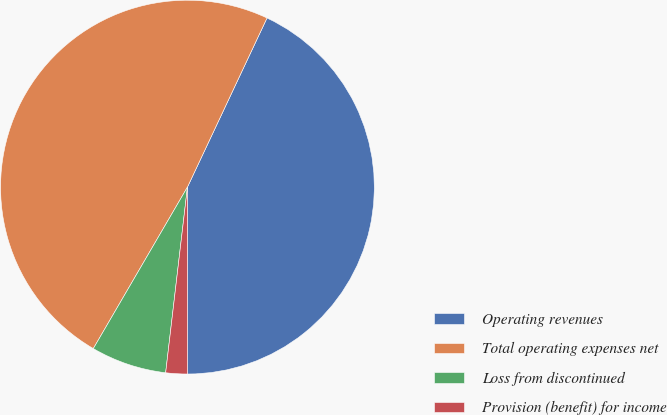Convert chart to OTSL. <chart><loc_0><loc_0><loc_500><loc_500><pie_chart><fcel>Operating revenues<fcel>Total operating expenses net<fcel>Loss from discontinued<fcel>Provision (benefit) for income<nl><fcel>42.99%<fcel>48.6%<fcel>6.54%<fcel>1.87%<nl></chart> 